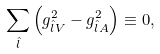<formula> <loc_0><loc_0><loc_500><loc_500>\sum _ { \hat { l } } \left ( g ^ { 2 } _ { \hat { l } V } - g ^ { 2 } _ { \hat { l } A } \right ) \equiv 0 ,</formula> 